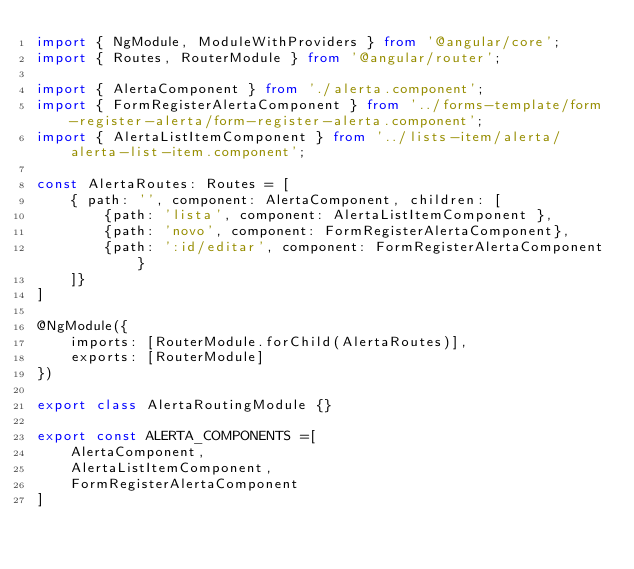Convert code to text. <code><loc_0><loc_0><loc_500><loc_500><_TypeScript_>import { NgModule, ModuleWithProviders } from '@angular/core';
import { Routes, RouterModule } from '@angular/router';

import { AlertaComponent } from './alerta.component';
import { FormRegisterAlertaComponent } from '../forms-template/form-register-alerta/form-register-alerta.component';
import { AlertaListItemComponent } from '../lists-item/alerta/alerta-list-item.component';

const AlertaRoutes: Routes = [
    { path: '', component: AlertaComponent, children: [
        {path: 'lista', component: AlertaListItemComponent },
        {path: 'novo', component: FormRegisterAlertaComponent},
        {path: ':id/editar', component: FormRegisterAlertaComponent}
    ]}
]

@NgModule({
    imports: [RouterModule.forChild(AlertaRoutes)],
    exports: [RouterModule]
})

export class AlertaRoutingModule {}

export const ALERTA_COMPONENTS =[
    AlertaComponent,
    AlertaListItemComponent,
    FormRegisterAlertaComponent
]</code> 